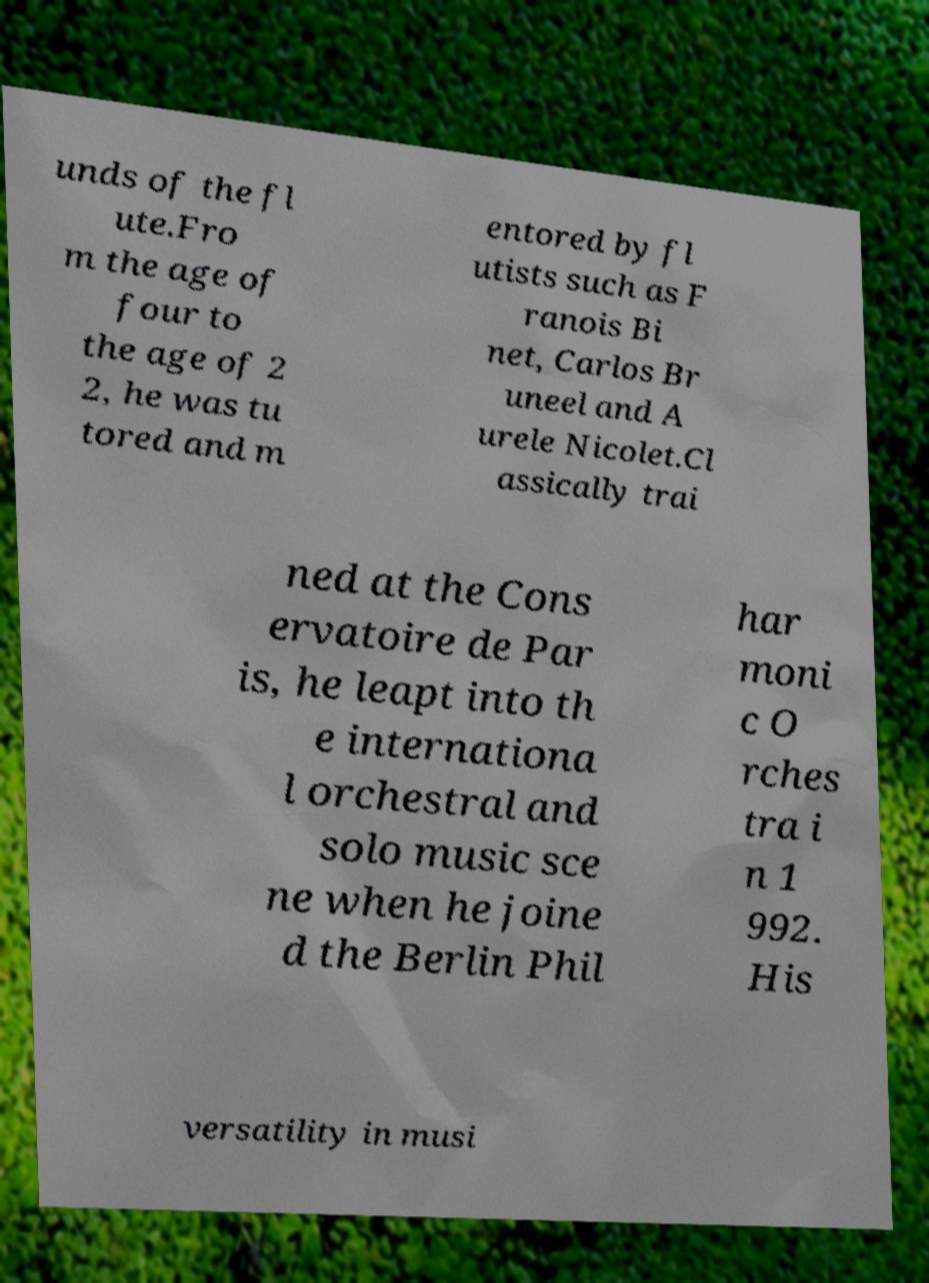For documentation purposes, I need the text within this image transcribed. Could you provide that? unds of the fl ute.Fro m the age of four to the age of 2 2, he was tu tored and m entored by fl utists such as F ranois Bi net, Carlos Br uneel and A urele Nicolet.Cl assically trai ned at the Cons ervatoire de Par is, he leapt into th e internationa l orchestral and solo music sce ne when he joine d the Berlin Phil har moni c O rches tra i n 1 992. His versatility in musi 